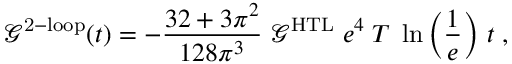Convert formula to latex. <formula><loc_0><loc_0><loc_500><loc_500>\mathcal { G } ^ { 2 - l o o p } ( t ) = - \frac { 3 2 + 3 \pi ^ { 2 } } { 1 2 8 \pi ^ { 3 } } \, \mathcal { G } ^ { H T L } \, e ^ { 4 } \, T \, \ln \left ( \frac { 1 } { e } \right ) \, t \, ,</formula> 